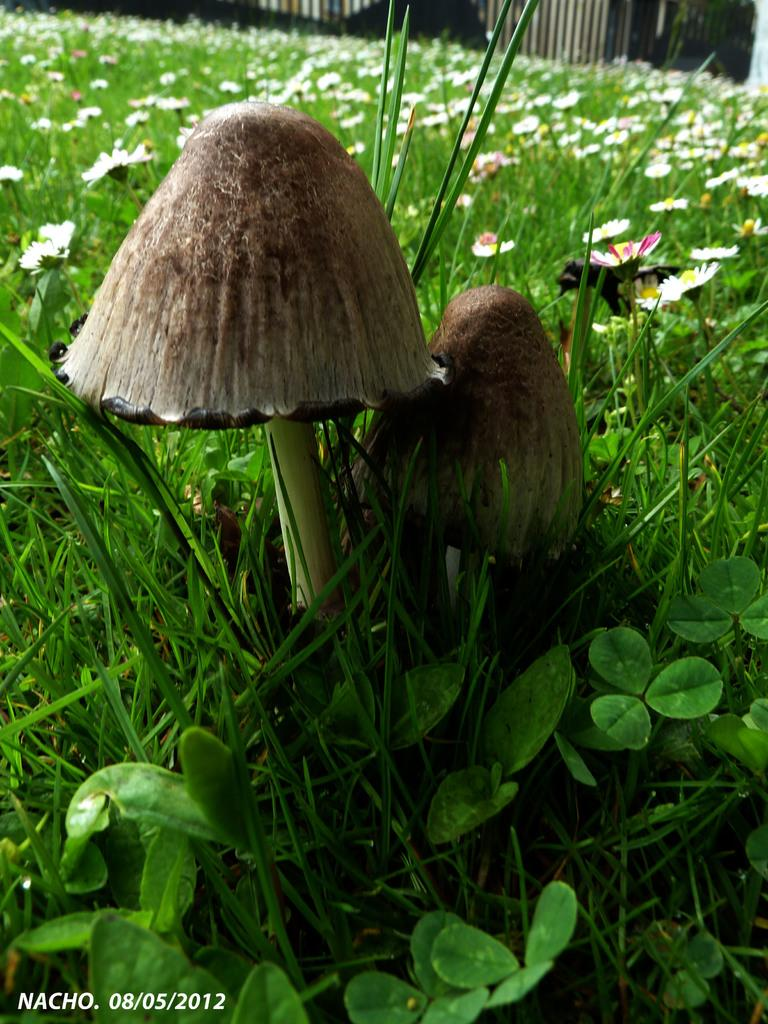What type of vegetation can be seen in the image? There are mushrooms, grass, and flowers in the image. What is the primary color of the grass in the image? The grass in the image is green. Can you describe any other features of the image? There is a watermark on the image. How many kittens are playing with the mushrooms in the image? There are no kittens present in the image; it only features mushrooms, grass, and flowers. What type of steam is visible coming from the flowers in the image? There is no steam visible in the image, as it only contains mushrooms, grass, and flowers. 